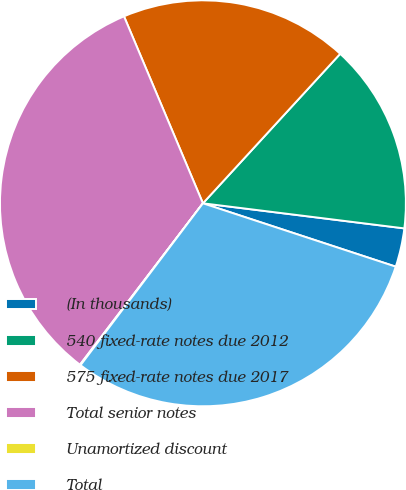<chart> <loc_0><loc_0><loc_500><loc_500><pie_chart><fcel>(In thousands)<fcel>540 fixed-rate notes due 2012<fcel>575 fixed-rate notes due 2017<fcel>Total senior notes<fcel>Unamortized discount<fcel>Total<nl><fcel>3.08%<fcel>15.15%<fcel>18.18%<fcel>33.28%<fcel>0.06%<fcel>30.25%<nl></chart> 